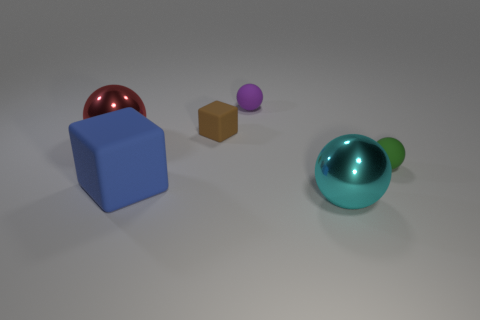Subtract all purple balls. How many balls are left? 3 Add 3 gray matte cubes. How many objects exist? 9 Subtract all gray spheres. Subtract all green cubes. How many spheres are left? 4 Add 4 gray rubber blocks. How many gray rubber blocks exist? 4 Subtract 1 purple balls. How many objects are left? 5 Subtract all cubes. How many objects are left? 4 Subtract all balls. Subtract all metal spheres. How many objects are left? 0 Add 6 red metallic balls. How many red metallic balls are left? 7 